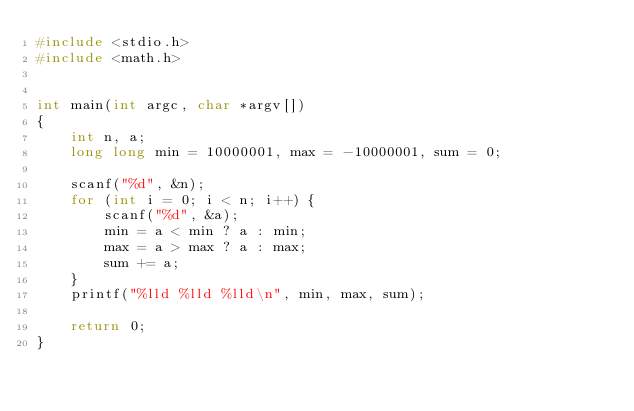Convert code to text. <code><loc_0><loc_0><loc_500><loc_500><_C_>#include <stdio.h>
#include <math.h>


int main(int argc, char *argv[])
{
    int n, a;
    long long min = 10000001, max = -10000001, sum = 0;

    scanf("%d", &n);
    for (int i = 0; i < n; i++) {
        scanf("%d", &a);
        min = a < min ? a : min;
        max = a > max ? a : max;
        sum += a;
    }
    printf("%lld %lld %lld\n", min, max, sum);

    return 0;
}
</code> 